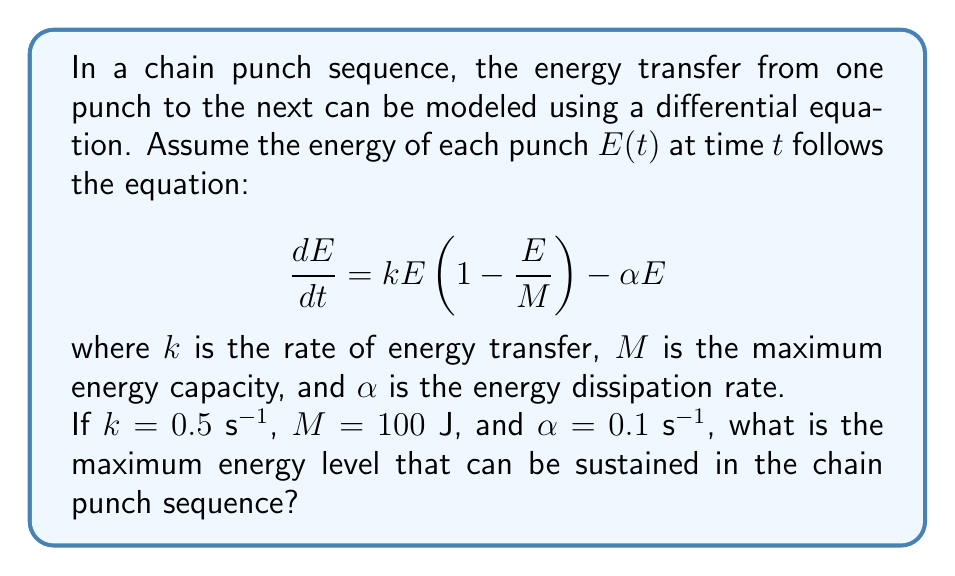Provide a solution to this math problem. To find the maximum sustainable energy level, we need to find the equilibrium point of the differential equation. At this point, the rate of change of energy will be zero:

$$\frac{dE}{dt} = 0$$

Substituting this into our original equation:

$$0 = kE(1 - \frac{E}{M}) - \alpha E$$

Now, let's substitute the given values:

$$0 = 0.5E(1 - \frac{E}{100}) - 0.1E$$

Simplifying:

$$0 = 0.5E - 0.005E^2 - 0.1E$$
$$0 = 0.4E - 0.005E^2$$

Factoring out $E$:

$$E(0.4 - 0.005E) = 0$$

This equation has two solutions: $E = 0$ or $0.4 - 0.005E = 0$

The non-zero solution is of interest to us. Solving $0.4 - 0.005E = 0$:

$$0.005E = 0.4$$
$$E = \frac{0.4}{0.005} = 80$$

Therefore, the maximum sustainable energy level is 80 J.
Answer: 80 J 